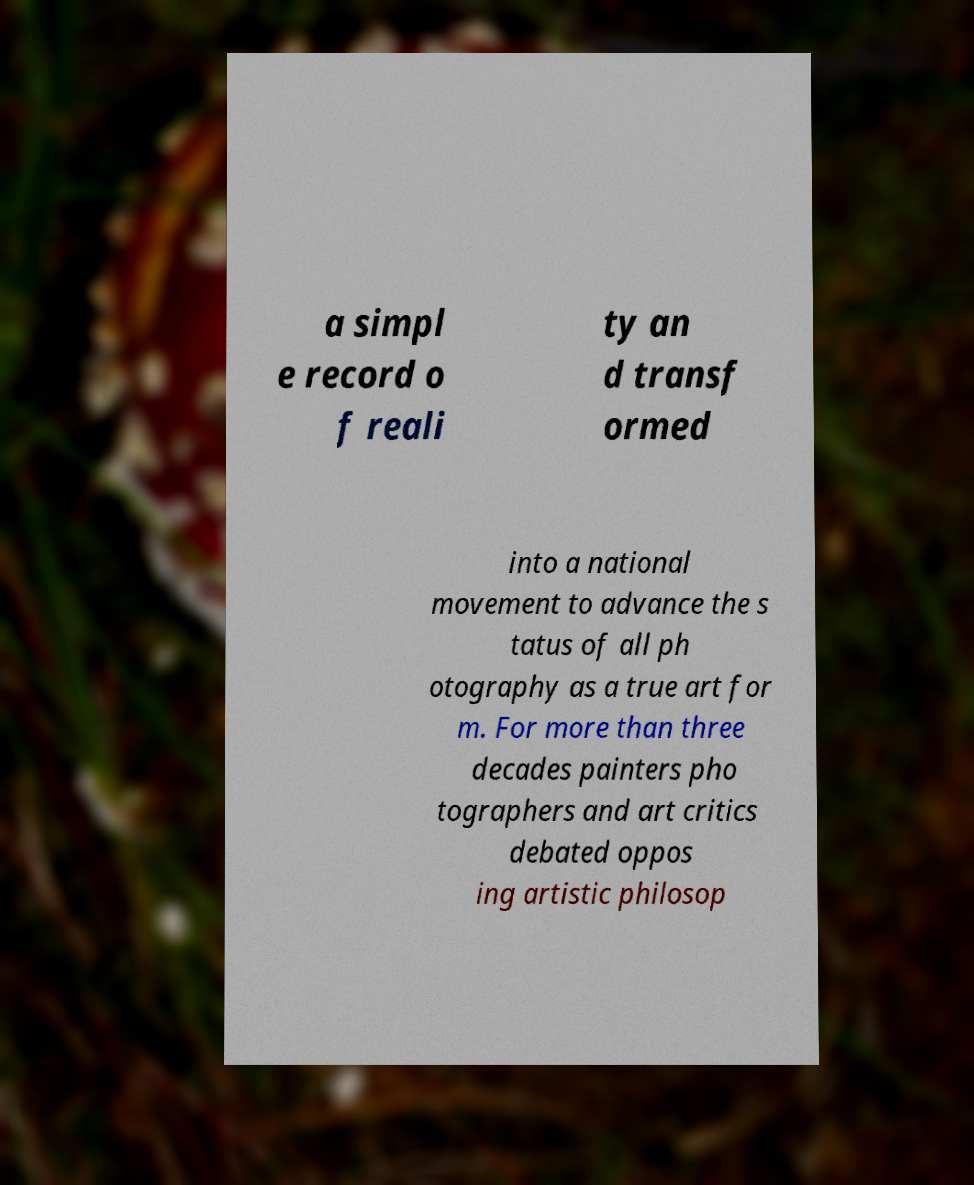I need the written content from this picture converted into text. Can you do that? a simpl e record o f reali ty an d transf ormed into a national movement to advance the s tatus of all ph otography as a true art for m. For more than three decades painters pho tographers and art critics debated oppos ing artistic philosop 